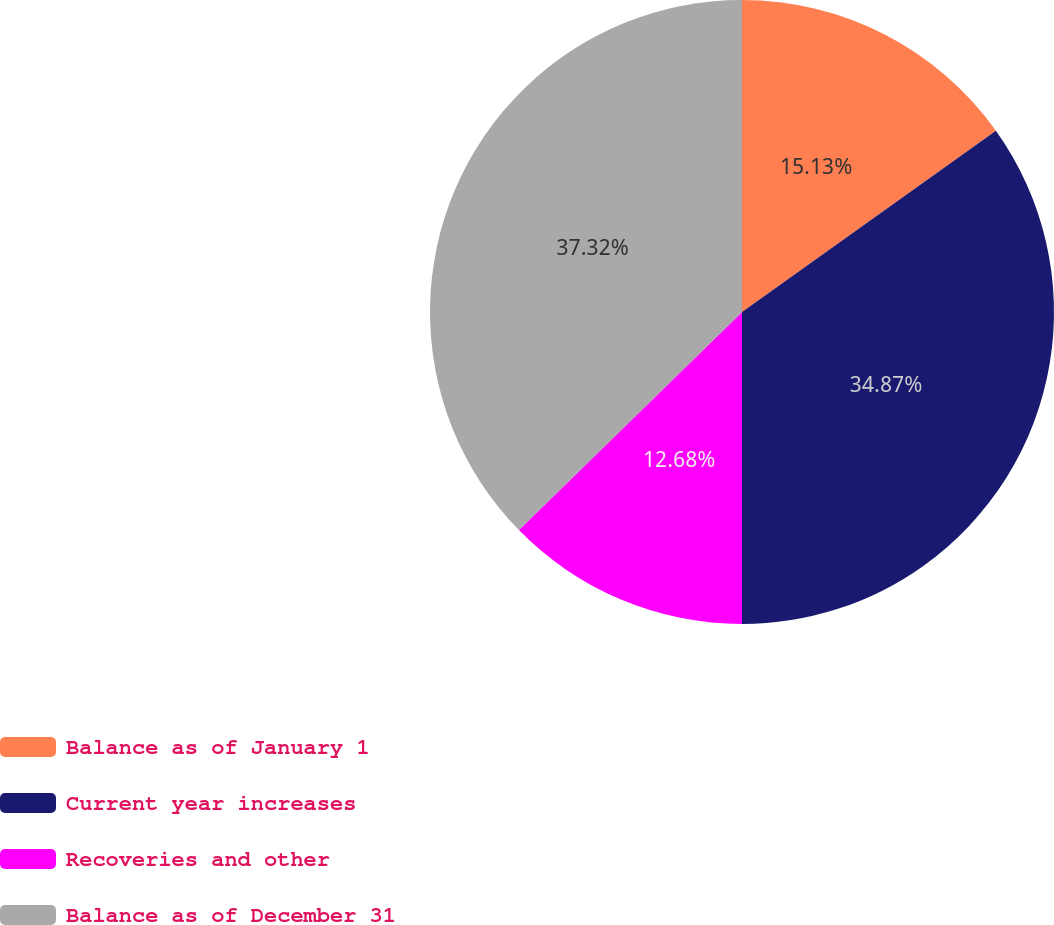<chart> <loc_0><loc_0><loc_500><loc_500><pie_chart><fcel>Balance as of January 1<fcel>Current year increases<fcel>Recoveries and other<fcel>Balance as of December 31<nl><fcel>15.13%<fcel>34.87%<fcel>12.68%<fcel>37.32%<nl></chart> 